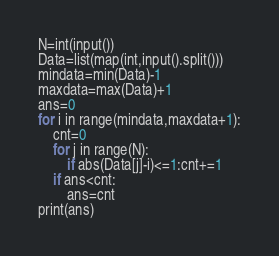<code> <loc_0><loc_0><loc_500><loc_500><_Python_>
N=int(input())
Data=list(map(int,input().split()))
mindata=min(Data)-1
maxdata=max(Data)+1
ans=0
for i in range(mindata,maxdata+1):
    cnt=0
    for j in range(N):
        if abs(Data[j]-i)<=1:cnt+=1
    if ans<cnt:
        ans=cnt
print(ans)
</code> 